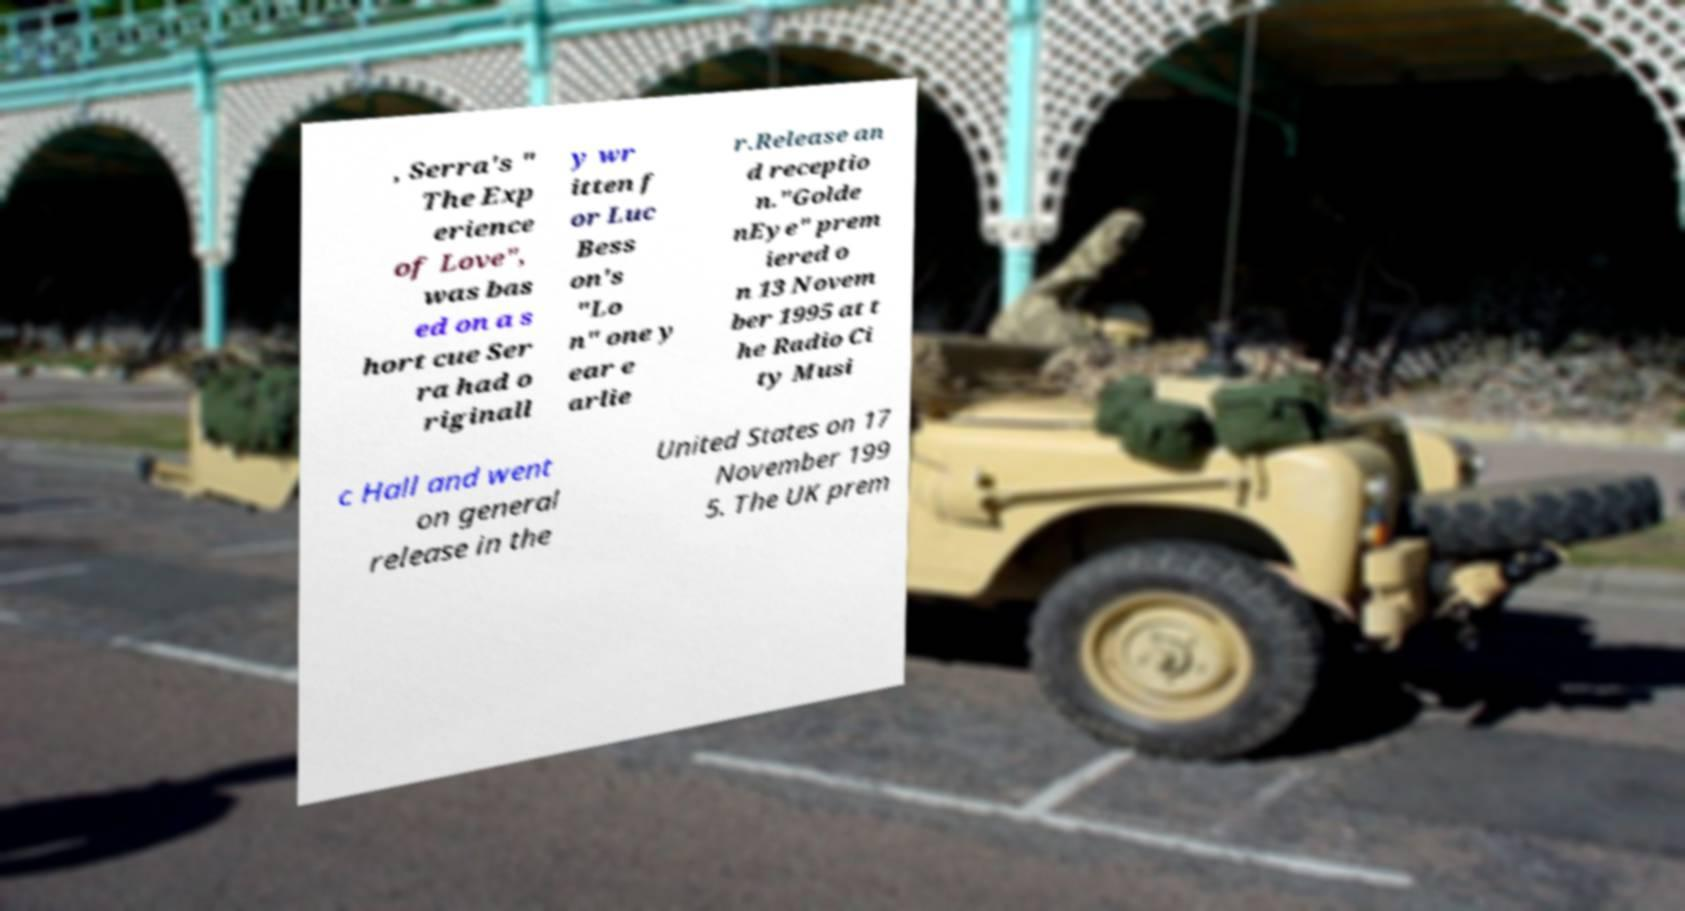Could you assist in decoding the text presented in this image and type it out clearly? , Serra's " The Exp erience of Love", was bas ed on a s hort cue Ser ra had o riginall y wr itten f or Luc Bess on's "Lo n" one y ear e arlie r.Release an d receptio n."Golde nEye" prem iered o n 13 Novem ber 1995 at t he Radio Ci ty Musi c Hall and went on general release in the United States on 17 November 199 5. The UK prem 